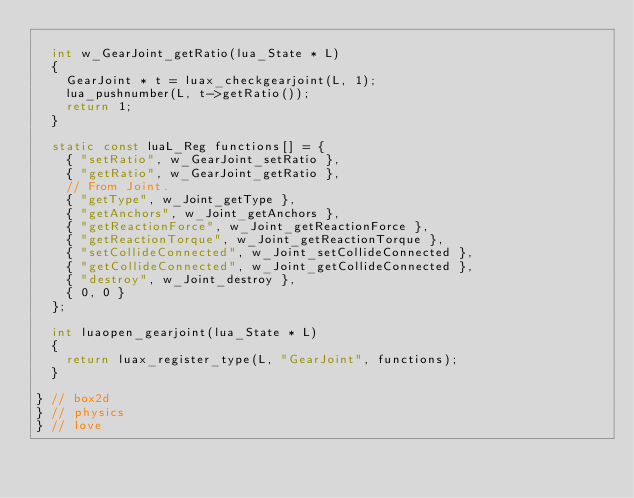Convert code to text. <code><loc_0><loc_0><loc_500><loc_500><_C++_>	
	int w_GearJoint_getRatio(lua_State * L)
	{
		GearJoint * t = luax_checkgearjoint(L, 1);
		lua_pushnumber(L, t->getRatio());
		return 1;
	}

	static const luaL_Reg functions[] = {
		{ "setRatio", w_GearJoint_setRatio },
		{ "getRatio", w_GearJoint_getRatio },
		// From Joint.
		{ "getType", w_Joint_getType },
		{ "getAnchors", w_Joint_getAnchors },
		{ "getReactionForce", w_Joint_getReactionForce },
		{ "getReactionTorque", w_Joint_getReactionTorque },
		{ "setCollideConnected", w_Joint_setCollideConnected },
		{ "getCollideConnected", w_Joint_getCollideConnected },
		{ "destroy", w_Joint_destroy },
		{ 0, 0 }
	};

	int luaopen_gearjoint(lua_State * L)
	{
		return luax_register_type(L, "GearJoint", functions);
	}

} // box2d
} // physics
} // love
</code> 